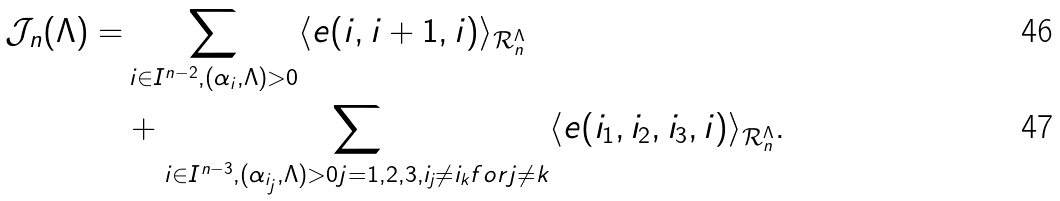<formula> <loc_0><loc_0><loc_500><loc_500>\mathcal { J } _ { n } ( \Lambda ) = & \sum _ { i \in I ^ { n - 2 } , ( \alpha _ { i } , \Lambda ) > 0 } \langle e ( i , i + 1 , i ) \rangle _ { \mathcal { R } _ { n } ^ { \Lambda } } \\ & + \sum _ { i \in I ^ { n - 3 } , ( \alpha _ { i _ { j } } , \Lambda ) > 0 j = 1 , 2 , 3 , i _ { j } \neq i _ { k } f o r j \neq k } \langle e ( i _ { 1 } , i _ { 2 } , i _ { 3 } , i ) \rangle _ { \mathcal { R } _ { n } ^ { \Lambda } } .</formula> 